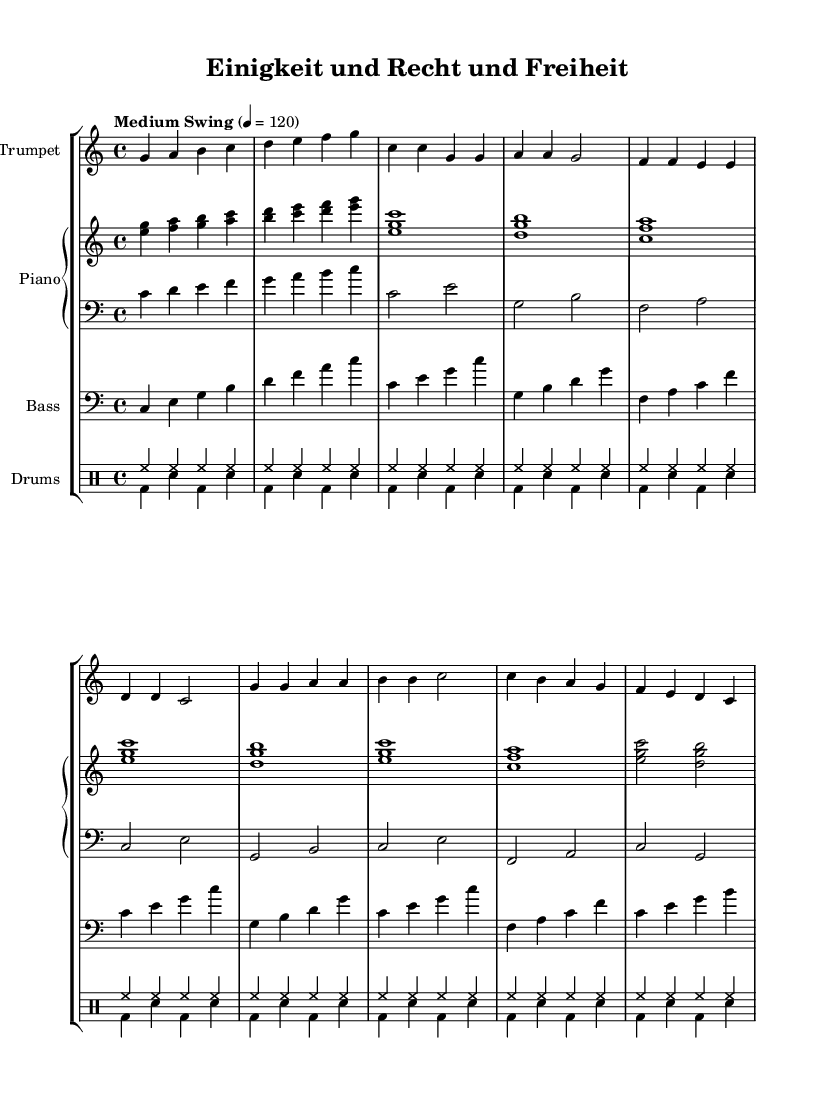What is the key signature of this music? The key signature is C major, which has no sharps or flats indicated at the beginning of the score.
Answer: C major What is the time signature of this piece? The time signature is indicated by the fraction at the beginning of the score, showing that there are four beats in each measure with a quarter note receiving one beat.
Answer: 4/4 What is the tempo indicated for the performance? The tempo is found in the tempo marks at the beginning of the score indicating the speed of the piece, which is set to "Medium Swing" with a metronome marking of 120 beats per minute.
Answer: Medium Swing 120 How many measures are in the verse section? By analyzing the music, we count each measure in the verse from the score, which consists of eight measures in total.
Answer: 8 What is the highest pitch note in the trumpet music? Looking at the trumpet music, the highest note is identified as the ‘b’ flats appearing in the chorus section, which is the peak of the melodic line.
Answer: B What is the rhythmic pattern used in the drum section? By examining the drum part, we notice it consists of a repeated pattern in the introductory and verse sections, where high-hat hits are steady and bass drum hits appear punctuated, characterizing the typical jazz rhythm.
Answer: Steady high-hat, punctuated bass drum What folk song does this jazz piece interpret? The title header of the sheet music indicates that this jazz interpretation is based on the German national anthem, known for its themes of unity and freedom.
Answer: Einigkeit und Recht und Freiheit 